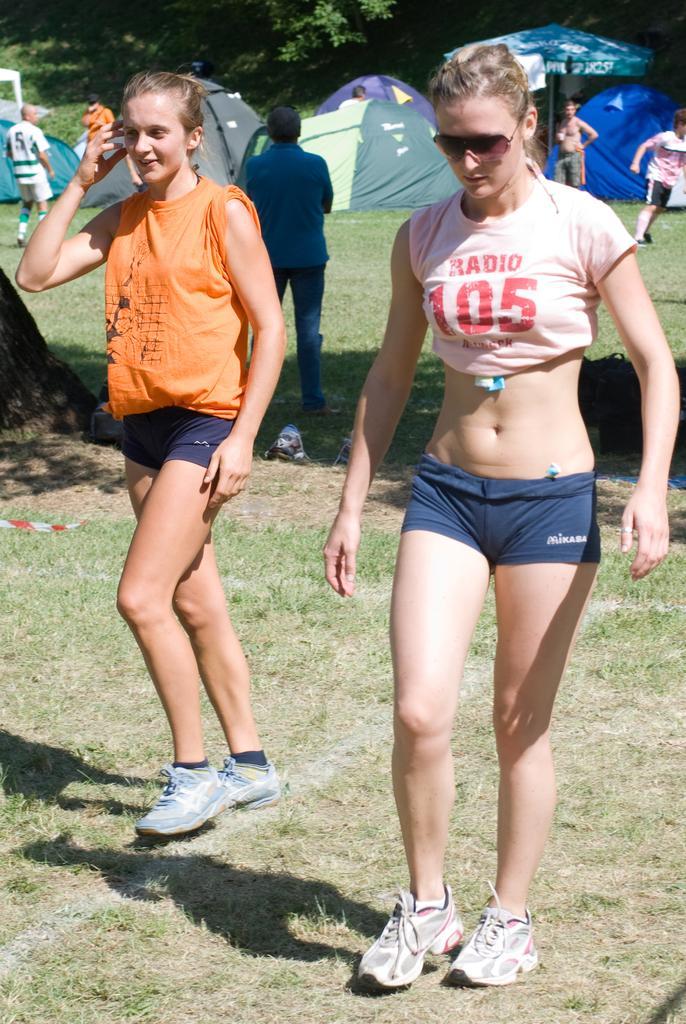How would you summarize this image in a sentence or two? In this image we can see two ladies, are walking and in the background, there are some people standing and we can see tents and trees. 